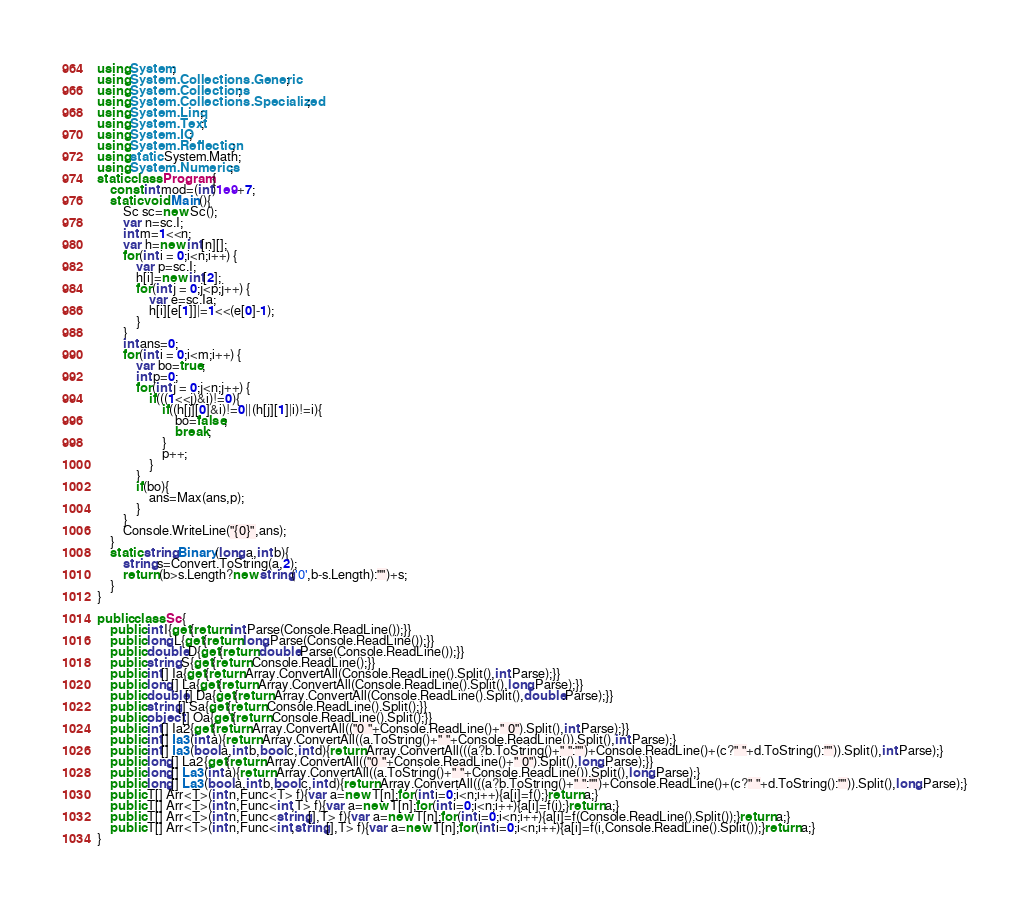<code> <loc_0><loc_0><loc_500><loc_500><_C#_>using System;
using System.Collections.Generic;
using System.Collections;
using System.Collections.Specialized;
using System.Linq;
using System.Text;
using System.IO;
using System.Reflection;
using static System.Math;
using System.Numerics;
static class Program{
	const int mod=(int)1e9+7;
	static void Main(){
		Sc sc=new Sc();
		var n=sc.I;
		int m=1<<n;
		var h=new int[n][];
		for(int i = 0;i<n;i++) {
			var p=sc.I;
			h[i]=new int[2];
			for(int j = 0;j<p;j++) {
				var e=sc.Ia;
				h[i][e[1]]|=1<<(e[0]-1);
			}
		}
		int ans=0;
		for(int i = 0;i<m;i++) {
			var bo=true;
			int p=0;
			for(int j = 0;j<n;j++) {
				if(((1<<j)&i)!=0){
					if((h[j][0]&i)!=0||(h[j][1]|i)!=i){
						bo=false;
						break;
					}
					p++;
				}
			}
			if(bo){
				ans=Max(ans,p);
			}
		}
		Console.WriteLine("{0}",ans);
	}
	static string Binary(long a,int b){
		string s=Convert.ToString(a,2);
		return (b>s.Length?new string('0',b-s.Length):"")+s;
	}
}

public class Sc{
	public int I{get{return int.Parse(Console.ReadLine());}}
	public long L{get{return long.Parse(Console.ReadLine());}}
	public double D{get{return double.Parse(Console.ReadLine());}}
	public string S{get{return Console.ReadLine();}}
	public int[] Ia{get{return Array.ConvertAll(Console.ReadLine().Split(),int.Parse);}}
	public long[] La{get{return Array.ConvertAll(Console.ReadLine().Split(),long.Parse);}}
	public double[] Da{get{return Array.ConvertAll(Console.ReadLine().Split(),double.Parse);}}
	public string[] Sa{get{return Console.ReadLine().Split();}}
	public object[] Oa{get{return Console.ReadLine().Split();}}
	public int[] Ia2{get{return Array.ConvertAll(("0 "+Console.ReadLine()+" 0").Split(),int.Parse);}}
	public int[] Ia3(int a){return Array.ConvertAll((a.ToString()+" "+Console.ReadLine()).Split(),int.Parse);}
	public int[] Ia3(bool a,int b,bool c,int d){return Array.ConvertAll(((a?b.ToString()+" ":"")+Console.ReadLine()+(c?" "+d.ToString():"")).Split(),int.Parse);}
	public long[] La2{get{return Array.ConvertAll(("0 "+Console.ReadLine()+" 0").Split(),long.Parse);}}
	public long[] La3(int a){return Array.ConvertAll((a.ToString()+" "+Console.ReadLine()).Split(),long.Parse);}
	public long[] La3(bool a,int b,bool c,int d){return Array.ConvertAll(((a?b.ToString()+" ":"")+Console.ReadLine()+(c?" "+d.ToString():"")).Split(),long.Parse);}
	public T[] Arr<T>(int n,Func<T> f){var a=new T[n];for(int i=0;i<n;i++){a[i]=f();}return a;}
	public T[] Arr<T>(int n,Func<int,T> f){var a=new T[n];for(int i=0;i<n;i++){a[i]=f(i);}return a;}
	public T[] Arr<T>(int n,Func<string[],T> f){var a=new T[n];for(int i=0;i<n;i++){a[i]=f(Console.ReadLine().Split());}return a;}
	public T[] Arr<T>(int n,Func<int,string[],T> f){var a=new T[n];for(int i=0;i<n;i++){a[i]=f(i,Console.ReadLine().Split());}return a;}
}</code> 